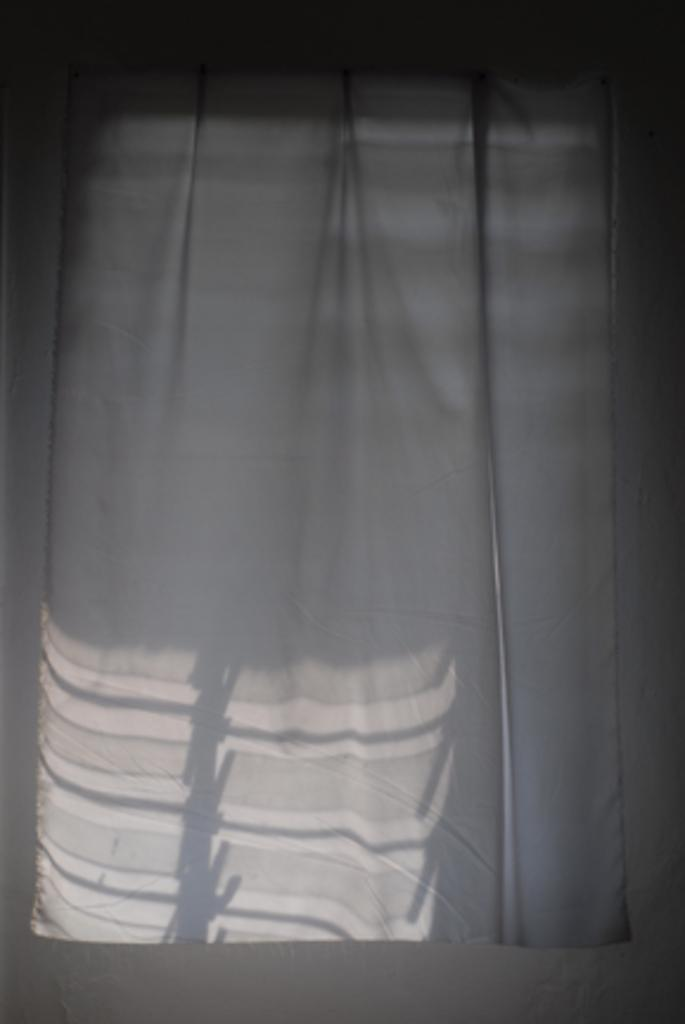What type of fabric is used for the curtain in the image? The curtain in the image is made of white fabric. How many books are stacked on the curtain in the image? There are no books present in the image; it only features a white curtain. 